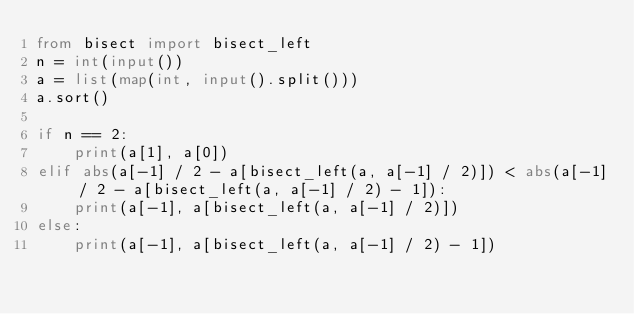<code> <loc_0><loc_0><loc_500><loc_500><_Python_>from bisect import bisect_left
n = int(input())
a = list(map(int, input().split()))
a.sort()

if n == 2:
    print(a[1], a[0])
elif abs(a[-1] / 2 - a[bisect_left(a, a[-1] / 2)]) < abs(a[-1] / 2 - a[bisect_left(a, a[-1] / 2) - 1]):
    print(a[-1], a[bisect_left(a, a[-1] / 2)])
else:
    print(a[-1], a[bisect_left(a, a[-1] / 2) - 1])</code> 